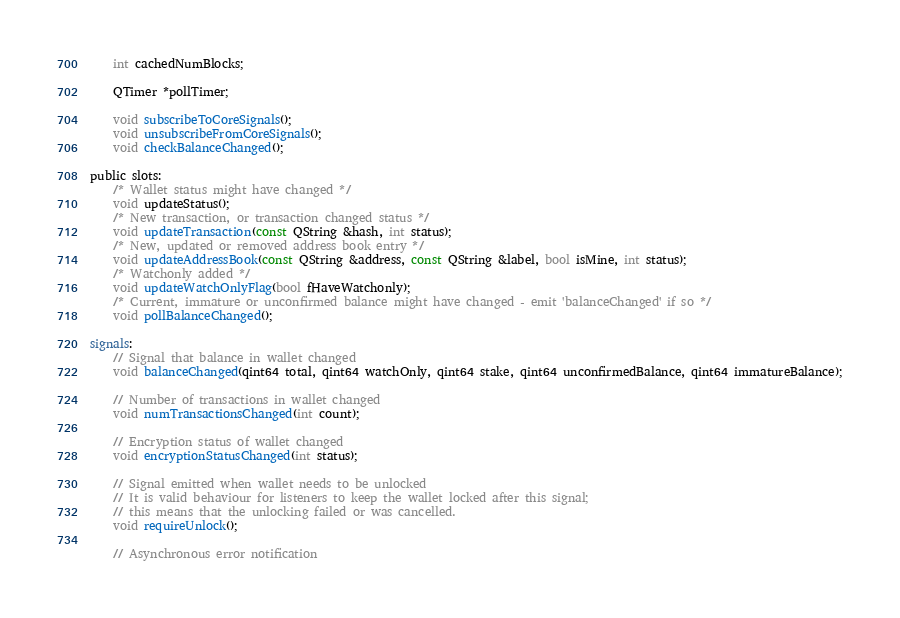Convert code to text. <code><loc_0><loc_0><loc_500><loc_500><_C_>    int cachedNumBlocks;

    QTimer *pollTimer;

    void subscribeToCoreSignals();
    void unsubscribeFromCoreSignals();
    void checkBalanceChanged();

public slots:
    /* Wallet status might have changed */
    void updateStatus();
    /* New transaction, or transaction changed status */
    void updateTransaction(const QString &hash, int status);
    /* New, updated or removed address book entry */
    void updateAddressBook(const QString &address, const QString &label, bool isMine, int status);
    /* Watchonly added */
    void updateWatchOnlyFlag(bool fHaveWatchonly);
    /* Current, immature or unconfirmed balance might have changed - emit 'balanceChanged' if so */
    void pollBalanceChanged();

signals:
    // Signal that balance in wallet changed
    void balanceChanged(qint64 total, qint64 watchOnly, qint64 stake, qint64 unconfirmedBalance, qint64 immatureBalance);

    // Number of transactions in wallet changed
    void numTransactionsChanged(int count);

    // Encryption status of wallet changed
    void encryptionStatusChanged(int status);

    // Signal emitted when wallet needs to be unlocked
    // It is valid behaviour for listeners to keep the wallet locked after this signal;
    // this means that the unlocking failed or was cancelled.
    void requireUnlock();

    // Asynchronous error notification</code> 